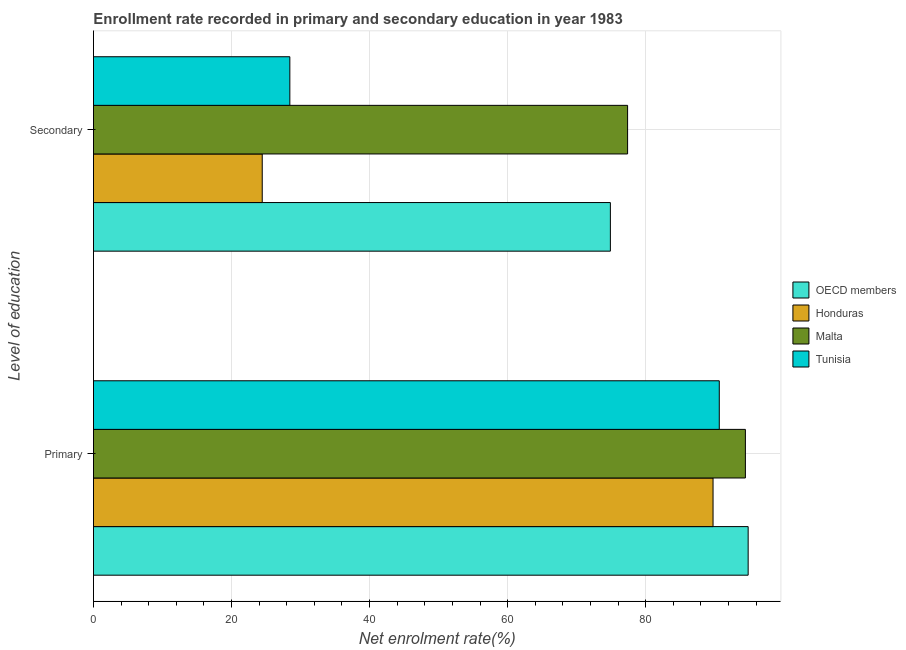How many different coloured bars are there?
Your response must be concise. 4. How many groups of bars are there?
Make the answer very short. 2. Are the number of bars per tick equal to the number of legend labels?
Make the answer very short. Yes. Are the number of bars on each tick of the Y-axis equal?
Ensure brevity in your answer.  Yes. What is the label of the 2nd group of bars from the top?
Provide a short and direct response. Primary. What is the enrollment rate in primary education in OECD members?
Give a very brief answer. 94.84. Across all countries, what is the maximum enrollment rate in secondary education?
Give a very brief answer. 77.38. Across all countries, what is the minimum enrollment rate in primary education?
Give a very brief answer. 89.76. In which country was the enrollment rate in primary education maximum?
Your response must be concise. OECD members. In which country was the enrollment rate in primary education minimum?
Make the answer very short. Honduras. What is the total enrollment rate in primary education in the graph?
Provide a succinct answer. 369.7. What is the difference between the enrollment rate in primary education in Tunisia and that in Honduras?
Make the answer very short. 0.9. What is the difference between the enrollment rate in secondary education in OECD members and the enrollment rate in primary education in Honduras?
Provide a succinct answer. -14.87. What is the average enrollment rate in secondary education per country?
Offer a terse response. 51.29. What is the difference between the enrollment rate in secondary education and enrollment rate in primary education in Malta?
Make the answer very short. -17.06. In how many countries, is the enrollment rate in primary education greater than 56 %?
Make the answer very short. 4. What is the ratio of the enrollment rate in secondary education in Tunisia to that in OECD members?
Provide a succinct answer. 0.38. Is the enrollment rate in primary education in OECD members less than that in Tunisia?
Offer a terse response. No. What does the 1st bar from the top in Primary represents?
Provide a short and direct response. Tunisia. What does the 4th bar from the bottom in Primary represents?
Your answer should be very brief. Tunisia. How many bars are there?
Your answer should be very brief. 8. How many countries are there in the graph?
Give a very brief answer. 4. Are the values on the major ticks of X-axis written in scientific E-notation?
Your answer should be compact. No. Does the graph contain grids?
Keep it short and to the point. Yes. Where does the legend appear in the graph?
Give a very brief answer. Center right. How are the legend labels stacked?
Keep it short and to the point. Vertical. What is the title of the graph?
Offer a very short reply. Enrollment rate recorded in primary and secondary education in year 1983. What is the label or title of the X-axis?
Your response must be concise. Net enrolment rate(%). What is the label or title of the Y-axis?
Offer a very short reply. Level of education. What is the Net enrolment rate(%) of OECD members in Primary?
Make the answer very short. 94.84. What is the Net enrolment rate(%) of Honduras in Primary?
Give a very brief answer. 89.76. What is the Net enrolment rate(%) in Malta in Primary?
Your response must be concise. 94.44. What is the Net enrolment rate(%) of Tunisia in Primary?
Your answer should be compact. 90.66. What is the Net enrolment rate(%) in OECD members in Secondary?
Your answer should be compact. 74.88. What is the Net enrolment rate(%) of Honduras in Secondary?
Keep it short and to the point. 24.45. What is the Net enrolment rate(%) in Malta in Secondary?
Offer a very short reply. 77.38. What is the Net enrolment rate(%) in Tunisia in Secondary?
Provide a succinct answer. 28.45. Across all Level of education, what is the maximum Net enrolment rate(%) of OECD members?
Make the answer very short. 94.84. Across all Level of education, what is the maximum Net enrolment rate(%) in Honduras?
Keep it short and to the point. 89.76. Across all Level of education, what is the maximum Net enrolment rate(%) in Malta?
Make the answer very short. 94.44. Across all Level of education, what is the maximum Net enrolment rate(%) in Tunisia?
Keep it short and to the point. 90.66. Across all Level of education, what is the minimum Net enrolment rate(%) in OECD members?
Keep it short and to the point. 74.88. Across all Level of education, what is the minimum Net enrolment rate(%) in Honduras?
Make the answer very short. 24.45. Across all Level of education, what is the minimum Net enrolment rate(%) of Malta?
Keep it short and to the point. 77.38. Across all Level of education, what is the minimum Net enrolment rate(%) in Tunisia?
Keep it short and to the point. 28.45. What is the total Net enrolment rate(%) of OECD members in the graph?
Keep it short and to the point. 169.73. What is the total Net enrolment rate(%) of Honduras in the graph?
Make the answer very short. 114.21. What is the total Net enrolment rate(%) of Malta in the graph?
Offer a very short reply. 171.82. What is the total Net enrolment rate(%) of Tunisia in the graph?
Give a very brief answer. 119.11. What is the difference between the Net enrolment rate(%) of OECD members in Primary and that in Secondary?
Give a very brief answer. 19.96. What is the difference between the Net enrolment rate(%) in Honduras in Primary and that in Secondary?
Your answer should be very brief. 65.31. What is the difference between the Net enrolment rate(%) of Malta in Primary and that in Secondary?
Ensure brevity in your answer.  17.06. What is the difference between the Net enrolment rate(%) in Tunisia in Primary and that in Secondary?
Your answer should be very brief. 62.21. What is the difference between the Net enrolment rate(%) of OECD members in Primary and the Net enrolment rate(%) of Honduras in Secondary?
Provide a succinct answer. 70.39. What is the difference between the Net enrolment rate(%) of OECD members in Primary and the Net enrolment rate(%) of Malta in Secondary?
Your response must be concise. 17.47. What is the difference between the Net enrolment rate(%) in OECD members in Primary and the Net enrolment rate(%) in Tunisia in Secondary?
Your response must be concise. 66.4. What is the difference between the Net enrolment rate(%) of Honduras in Primary and the Net enrolment rate(%) of Malta in Secondary?
Provide a succinct answer. 12.38. What is the difference between the Net enrolment rate(%) of Honduras in Primary and the Net enrolment rate(%) of Tunisia in Secondary?
Your response must be concise. 61.31. What is the difference between the Net enrolment rate(%) in Malta in Primary and the Net enrolment rate(%) in Tunisia in Secondary?
Provide a succinct answer. 65.99. What is the average Net enrolment rate(%) in OECD members per Level of education?
Offer a terse response. 84.86. What is the average Net enrolment rate(%) of Honduras per Level of education?
Your answer should be very brief. 57.1. What is the average Net enrolment rate(%) in Malta per Level of education?
Provide a short and direct response. 85.91. What is the average Net enrolment rate(%) of Tunisia per Level of education?
Make the answer very short. 59.55. What is the difference between the Net enrolment rate(%) of OECD members and Net enrolment rate(%) of Honduras in Primary?
Make the answer very short. 5.09. What is the difference between the Net enrolment rate(%) in OECD members and Net enrolment rate(%) in Malta in Primary?
Make the answer very short. 0.4. What is the difference between the Net enrolment rate(%) in OECD members and Net enrolment rate(%) in Tunisia in Primary?
Keep it short and to the point. 4.18. What is the difference between the Net enrolment rate(%) of Honduras and Net enrolment rate(%) of Malta in Primary?
Give a very brief answer. -4.69. What is the difference between the Net enrolment rate(%) in Honduras and Net enrolment rate(%) in Tunisia in Primary?
Your answer should be compact. -0.9. What is the difference between the Net enrolment rate(%) in Malta and Net enrolment rate(%) in Tunisia in Primary?
Offer a very short reply. 3.78. What is the difference between the Net enrolment rate(%) in OECD members and Net enrolment rate(%) in Honduras in Secondary?
Keep it short and to the point. 50.43. What is the difference between the Net enrolment rate(%) of OECD members and Net enrolment rate(%) of Malta in Secondary?
Offer a very short reply. -2.5. What is the difference between the Net enrolment rate(%) of OECD members and Net enrolment rate(%) of Tunisia in Secondary?
Provide a short and direct response. 46.43. What is the difference between the Net enrolment rate(%) of Honduras and Net enrolment rate(%) of Malta in Secondary?
Your answer should be compact. -52.93. What is the difference between the Net enrolment rate(%) in Honduras and Net enrolment rate(%) in Tunisia in Secondary?
Offer a terse response. -4. What is the difference between the Net enrolment rate(%) in Malta and Net enrolment rate(%) in Tunisia in Secondary?
Provide a short and direct response. 48.93. What is the ratio of the Net enrolment rate(%) in OECD members in Primary to that in Secondary?
Make the answer very short. 1.27. What is the ratio of the Net enrolment rate(%) of Honduras in Primary to that in Secondary?
Offer a very short reply. 3.67. What is the ratio of the Net enrolment rate(%) in Malta in Primary to that in Secondary?
Your answer should be very brief. 1.22. What is the ratio of the Net enrolment rate(%) in Tunisia in Primary to that in Secondary?
Provide a short and direct response. 3.19. What is the difference between the highest and the second highest Net enrolment rate(%) of OECD members?
Keep it short and to the point. 19.96. What is the difference between the highest and the second highest Net enrolment rate(%) in Honduras?
Ensure brevity in your answer.  65.31. What is the difference between the highest and the second highest Net enrolment rate(%) in Malta?
Keep it short and to the point. 17.06. What is the difference between the highest and the second highest Net enrolment rate(%) of Tunisia?
Make the answer very short. 62.21. What is the difference between the highest and the lowest Net enrolment rate(%) of OECD members?
Your answer should be compact. 19.96. What is the difference between the highest and the lowest Net enrolment rate(%) in Honduras?
Provide a short and direct response. 65.31. What is the difference between the highest and the lowest Net enrolment rate(%) of Malta?
Ensure brevity in your answer.  17.06. What is the difference between the highest and the lowest Net enrolment rate(%) in Tunisia?
Give a very brief answer. 62.21. 